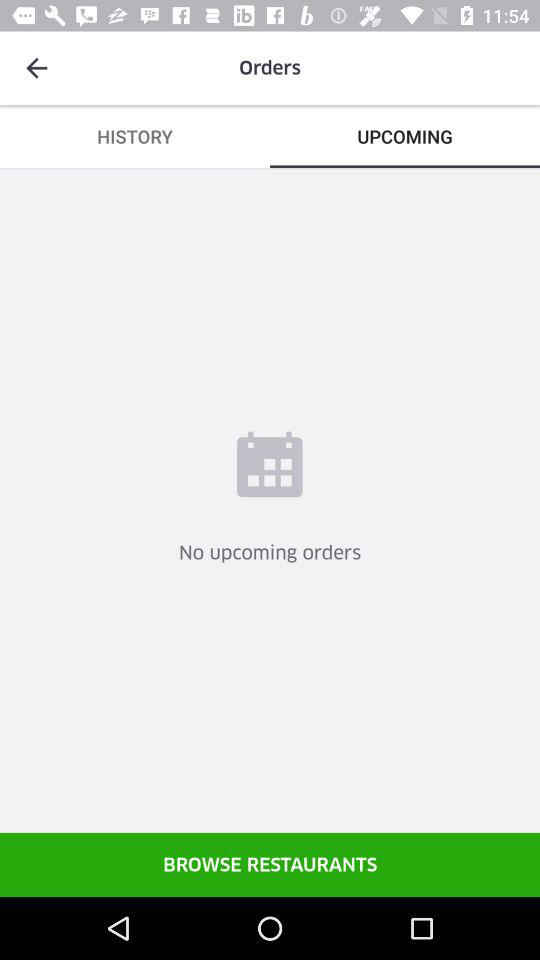Which option is selected in the "Orders" menu? The selected option in the "Orders" menu is "UPCOMING". 